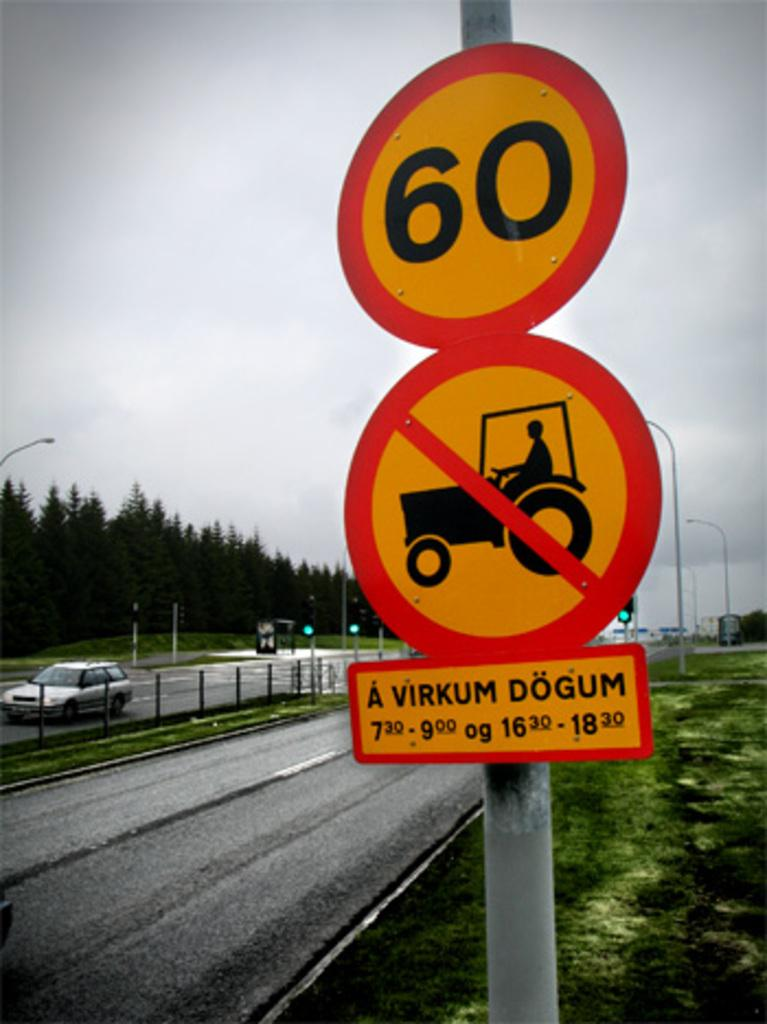<image>
Present a compact description of the photo's key features. A sign showing no tractors and A Virkum Dogum. 